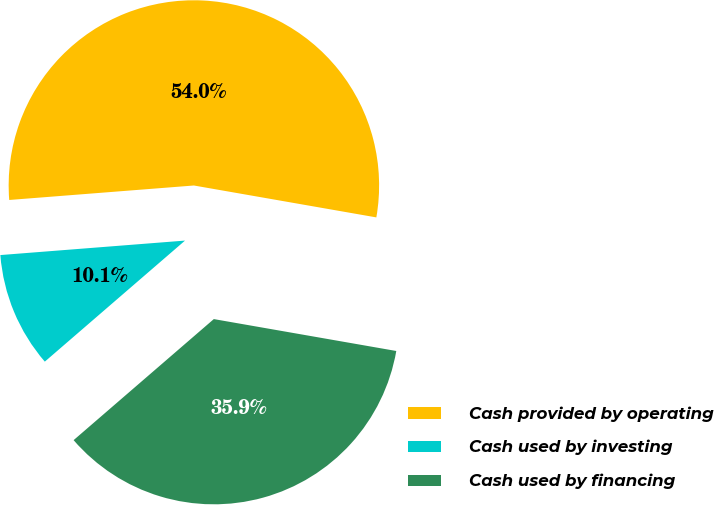<chart> <loc_0><loc_0><loc_500><loc_500><pie_chart><fcel>Cash provided by operating<fcel>Cash used by investing<fcel>Cash used by financing<nl><fcel>54.0%<fcel>10.09%<fcel>35.91%<nl></chart> 